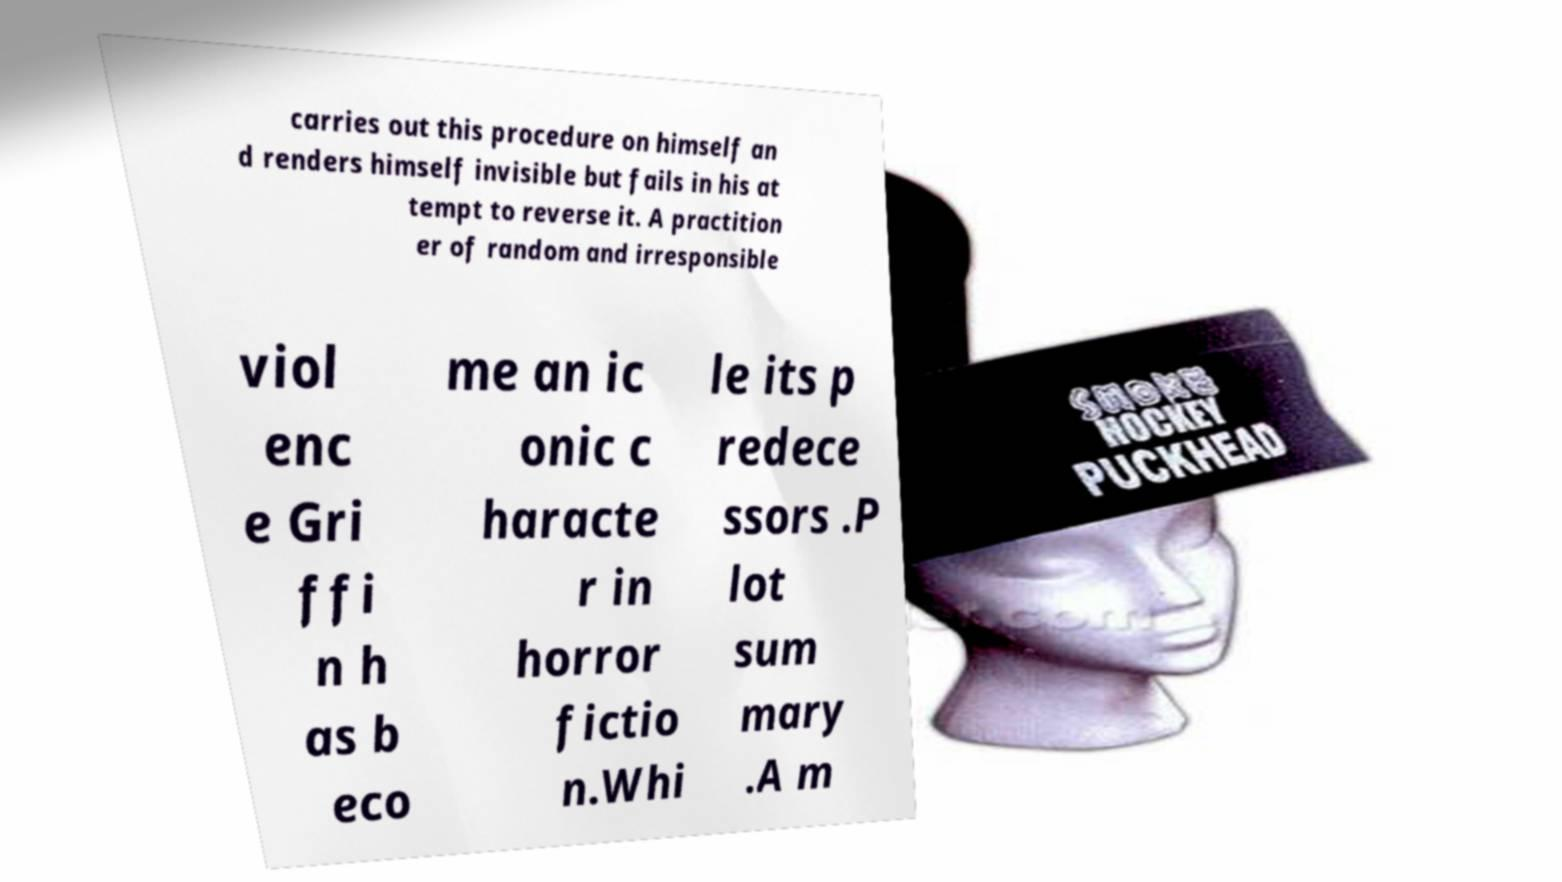Can you accurately transcribe the text from the provided image for me? carries out this procedure on himself an d renders himself invisible but fails in his at tempt to reverse it. A practition er of random and irresponsible viol enc e Gri ffi n h as b eco me an ic onic c haracte r in horror fictio n.Whi le its p redece ssors .P lot sum mary .A m 